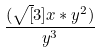<formula> <loc_0><loc_0><loc_500><loc_500>\frac { ( \sqrt { [ } 3 ] { x * y ^ { 2 } ) } } { y ^ { 3 } }</formula> 